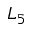<formula> <loc_0><loc_0><loc_500><loc_500>L _ { 5 }</formula> 